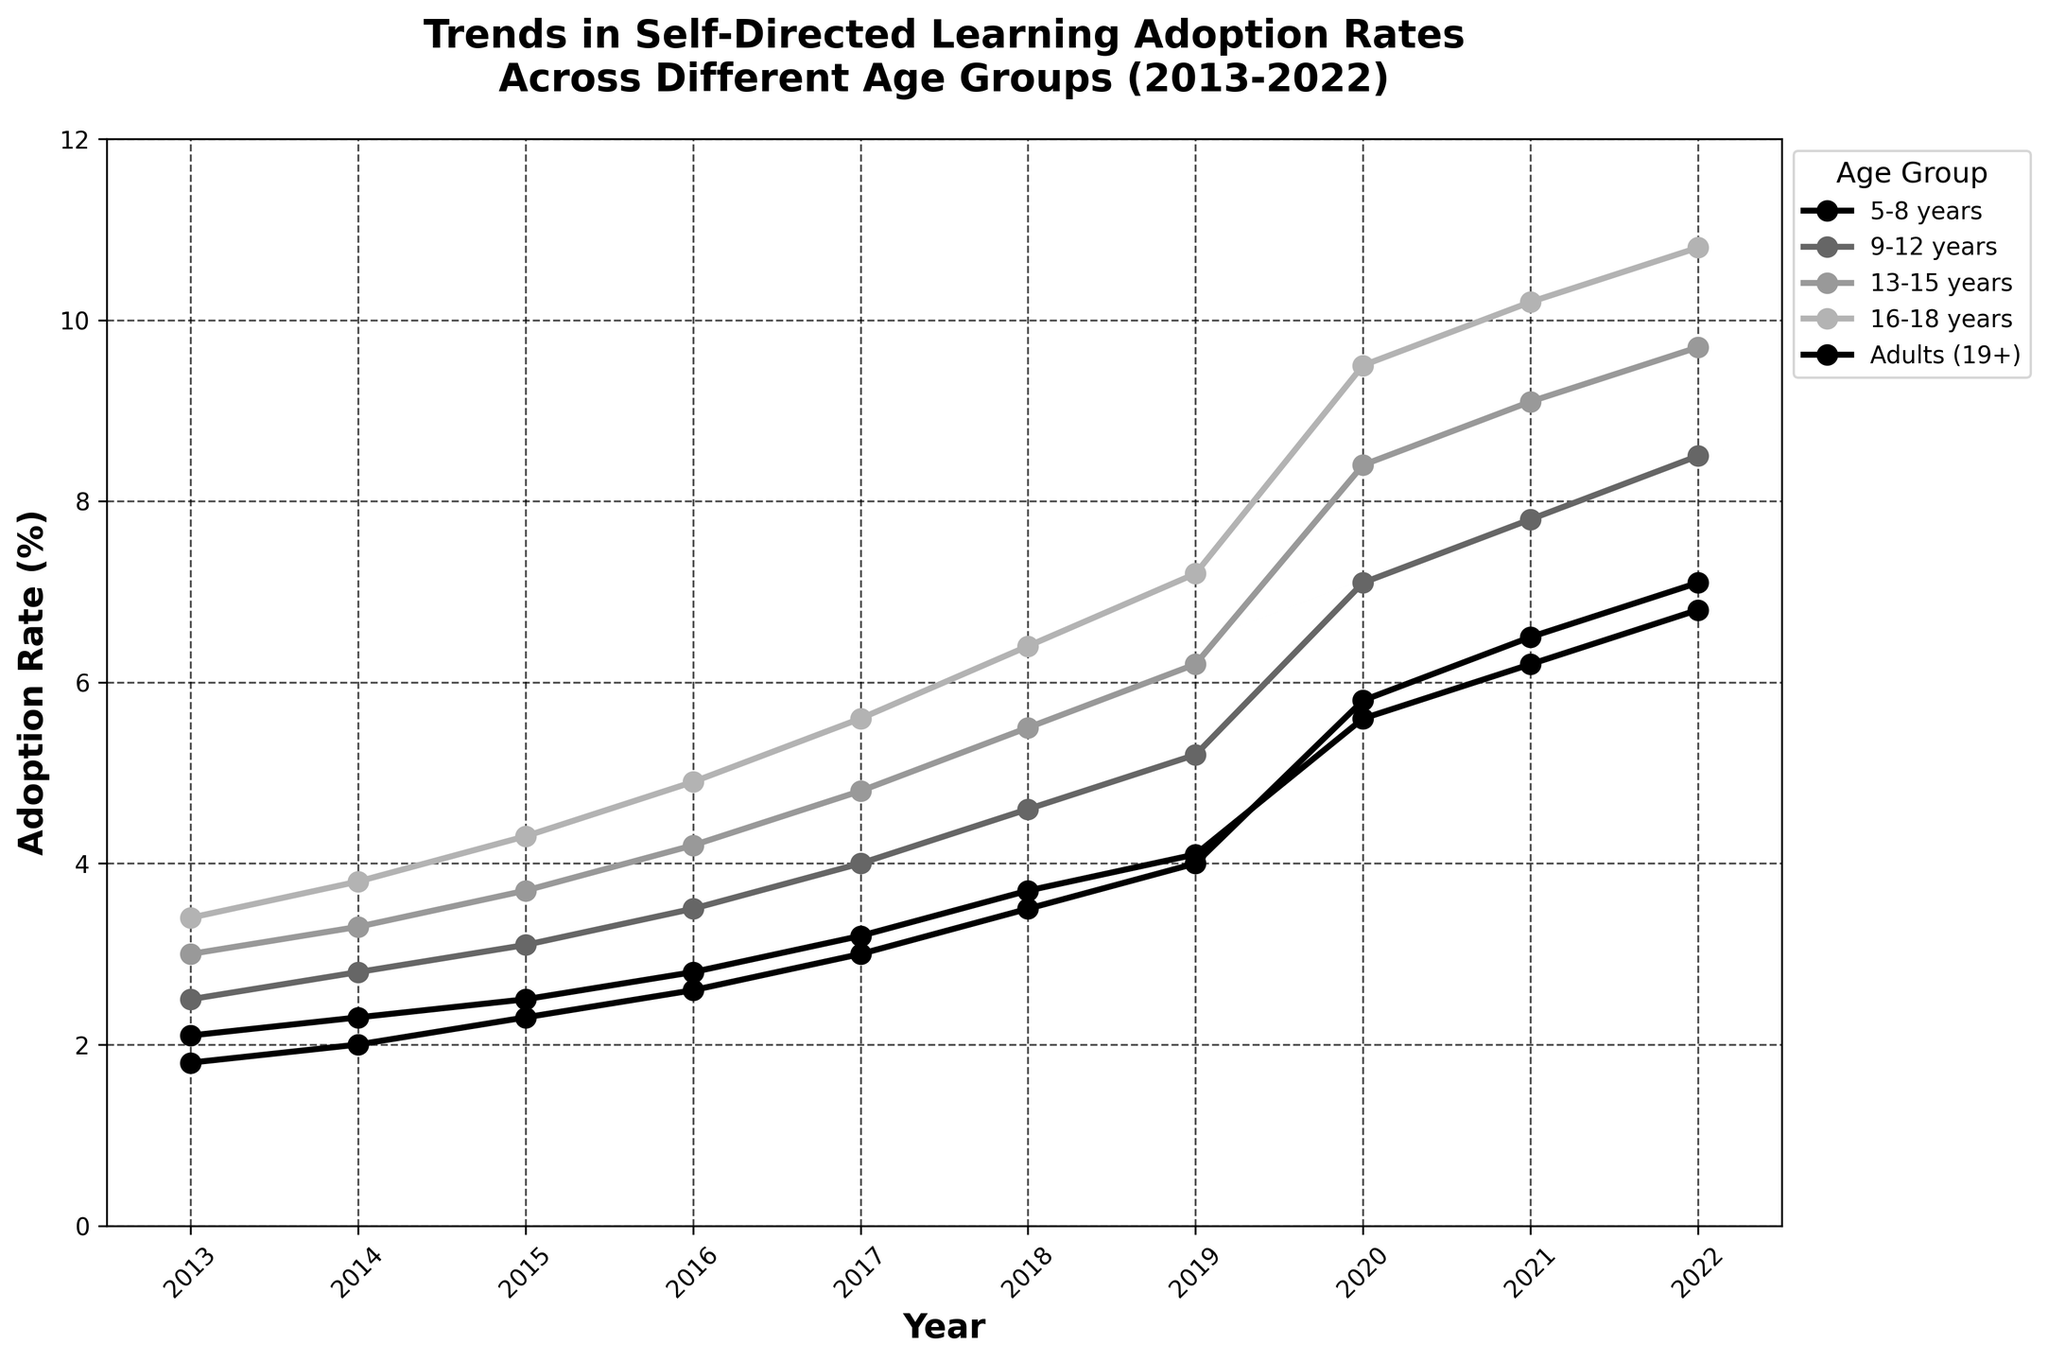What's the overall trend in self-directed learning adoption rates for the age group 5-8 years from 2013 to 2022? To determine the overall trend, observe the plotted line for the 5-8 years age group. The line starts at 2.1% in 2013 and steadily increases to 6.8% in 2022, indicating an upward trend in adoption rates.
Answer: Upward trend Which age group had the highest adoption rate in 2022? To find this, check the plotted lines for each age group at the year 2022. The highest value at 2022 corresponds to the 16-18 years age group, with an adoption rate of 10.8%.
Answer: 16-18 years In which year did the age group 13-15 years exceed a 5% adoption rate? Look at the plotted line for the 13-15 years age group and locate when the line crosses the 5% mark. The adoption rate exceeded 5% in the year 2018.
Answer: 2018 How does the adoption rate for adults (19+) in 2022 compare to that of the 9-12 years age group in the same year? Check the values for both age groups in 2022. The adoption rate for adults (19+) is 7.1%, while for the 9-12 years age group, it is 8.5%. Therefore, the rate for adults is lower.
Answer: Lower What is the average adoption rate for the age group 16-18 years from 2013 to 2017? Calculate the average for the years 2013 to 2017 for the 16-18 years age group. Sum the values (3.4 + 3.8 + 4.3 + 4.9 + 5.6) which equals 22. Then, divide by 5 years: 22 / 5 = 4.4%.
Answer: 4.4% By how much did the adoption rate for the 5-8 years age group increase from 2013 to 2022? Subtract the 2013 value from the 2022 value for the 5-8 years age group: 6.8% - 2.1% = 4.7%.
Answer: 4.7% Which age group showed the most significant increase in adoption rate between 2018 and 2022? Calculate the difference in rates between 2018 and 2022 for each age group. The most significant increase is for the 16-18 years age group, jumping from 6.4% in 2018 to 10.8% in 2022 (4.4% increase).
Answer: 16-18 years How does the adoption rate trend for 13-15 years compare to that for adults (19+) over the decade? Compare the slopes of the lines for both groups. Both increase over time, but the 13-15 years group starts at a higher rate and grows more quickly, especially after 2018.
Answer: 13-15 years grows faster In which year did all age groups have an increase in adoption rate compared to the previous year? By looking at the slopes of all lines year by year, we observe an upward trend between 2019 and 2020 for all age groups.
Answer: 2020 